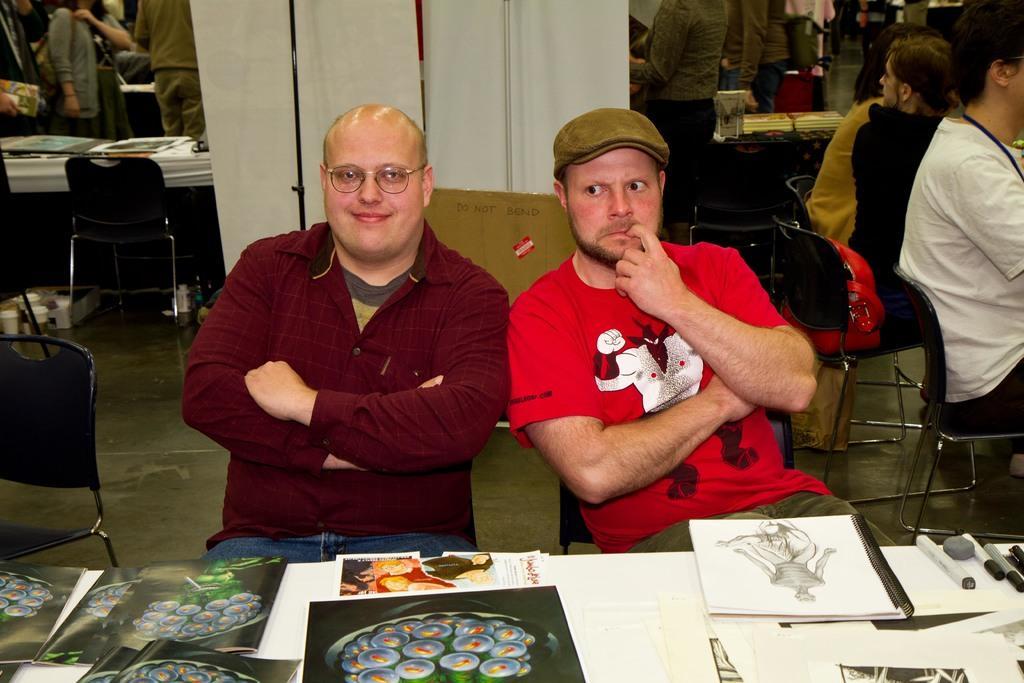How would you summarize this image in a sentence or two? In this image two persons are sitting on chairs on foreground. In front of them on a table there are paintings. In the background there are few other people, tables, chairs. On the table there are books. Here there is a screen. 